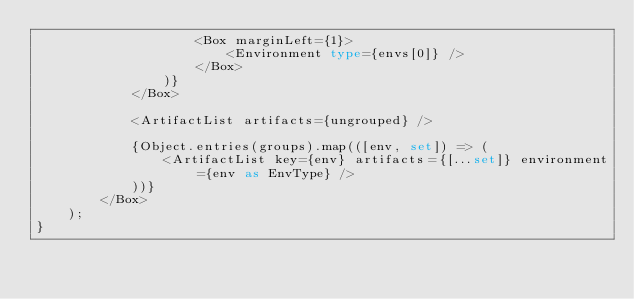<code> <loc_0><loc_0><loc_500><loc_500><_TypeScript_>					<Box marginLeft={1}>
						<Environment type={envs[0]} />
					</Box>
				)}
			</Box>

			<ArtifactList artifacts={ungrouped} />

			{Object.entries(groups).map(([env, set]) => (
				<ArtifactList key={env} artifacts={[...set]} environment={env as EnvType} />
			))}
		</Box>
	);
}
</code> 